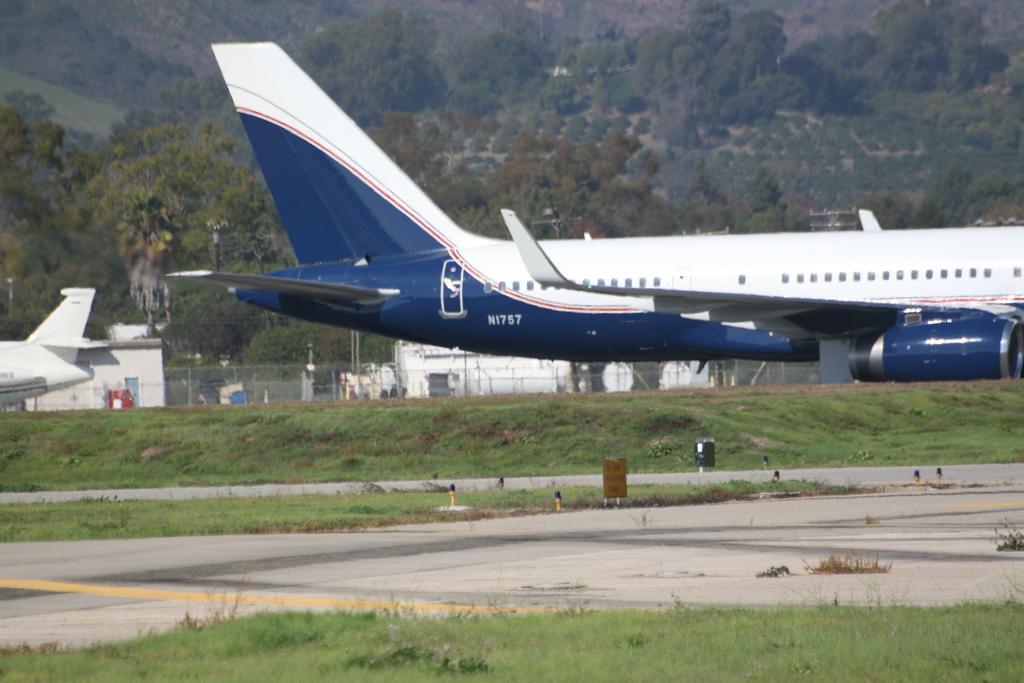What number is this airplane?
Ensure brevity in your answer.  N1757. 